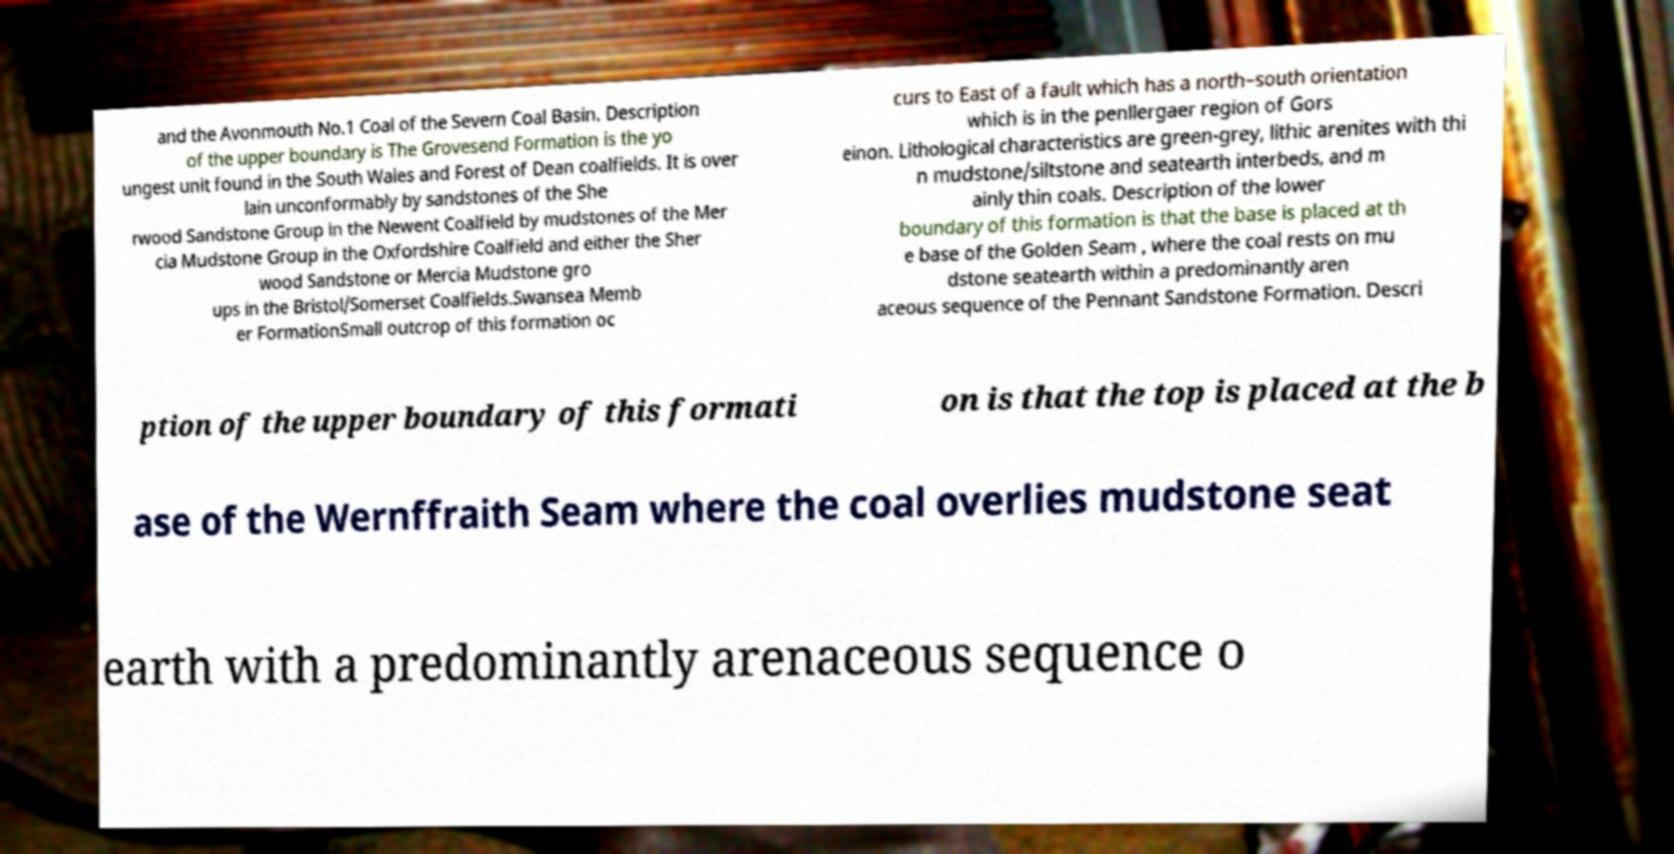Could you extract and type out the text from this image? and the Avonmouth No.1 Coal of the Severn Coal Basin. Description of the upper boundary is The Grovesend Formation is the yo ungest unit found in the South Wales and Forest of Dean coalfields. It is over lain unconformably by sandstones of the She rwood Sandstone Group in the Newent Coalfield by mudstones of the Mer cia Mudstone Group in the Oxfordshire Coalfield and either the Sher wood Sandstone or Mercia Mudstone gro ups in the Bristol/Somerset Coalfields.Swansea Memb er FormationSmall outcrop of this formation oc curs to East of a fault which has a north–south orientation which is in the penllergaer region of Gors einon. Lithological characteristics are green-grey, lithic arenites with thi n mudstone/siltstone and seatearth interbeds, and m ainly thin coals. Description of the lower boundary of this formation is that the base is placed at th e base of the Golden Seam , where the coal rests on mu dstone seatearth within a predominantly aren aceous sequence of the Pennant Sandstone Formation. Descri ption of the upper boundary of this formati on is that the top is placed at the b ase of the Wernffraith Seam where the coal overlies mudstone seat earth with a predominantly arenaceous sequence o 